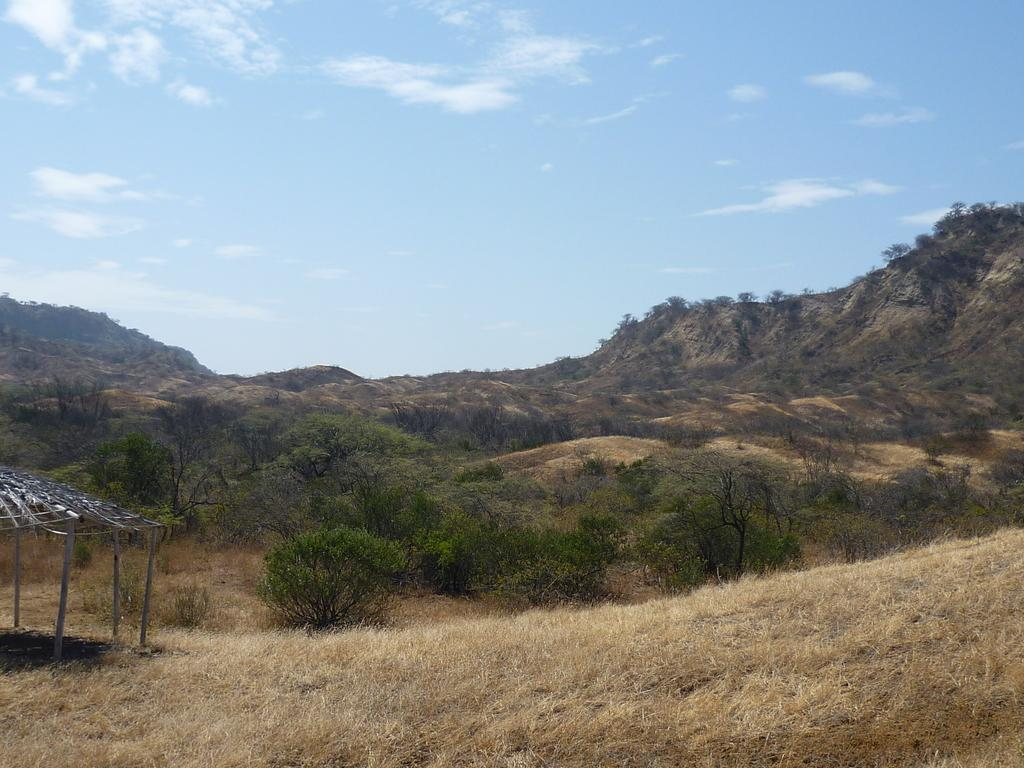What type of terrain is visible at the bottom of the image? There is dried grass land at the bottom side of the image. What structure can be seen on the left side of the image? There is a shed on the left side of the image. What type of vegetation is in the center of the image? There are trees in the center of the image. What type of pies is the band selling in the image? There is no band or pies present in the image. 